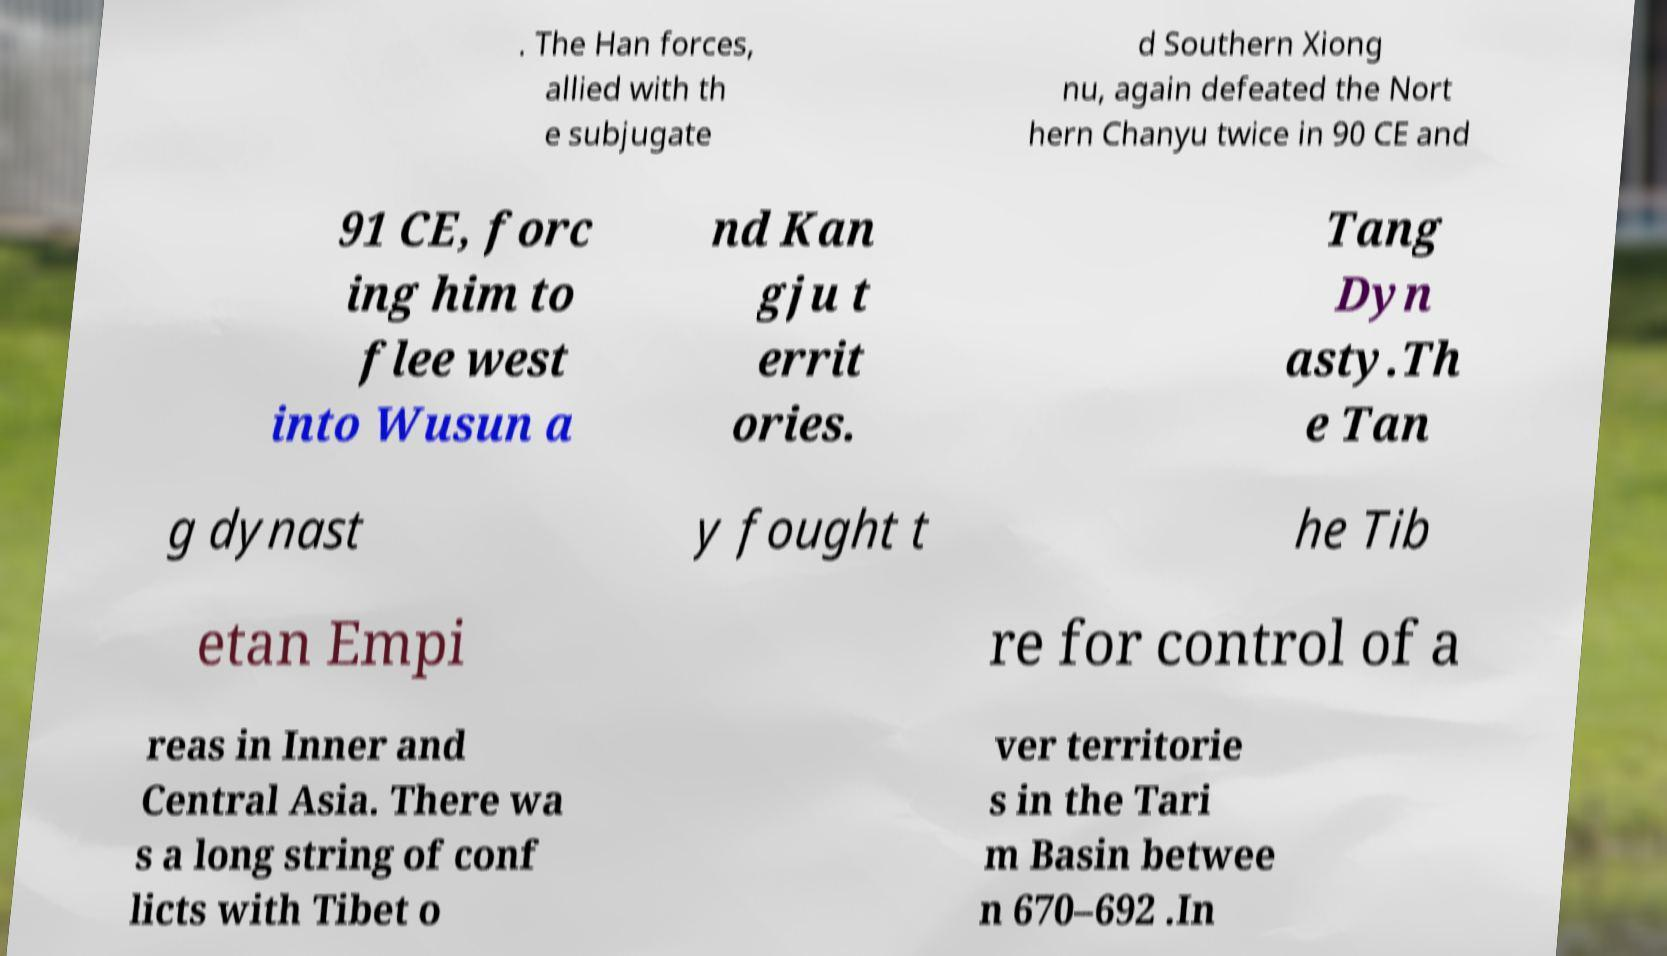I need the written content from this picture converted into text. Can you do that? . The Han forces, allied with th e subjugate d Southern Xiong nu, again defeated the Nort hern Chanyu twice in 90 CE and 91 CE, forc ing him to flee west into Wusun a nd Kan gju t errit ories. Tang Dyn asty.Th e Tan g dynast y fought t he Tib etan Empi re for control of a reas in Inner and Central Asia. There wa s a long string of conf licts with Tibet o ver territorie s in the Tari m Basin betwee n 670–692 .In 